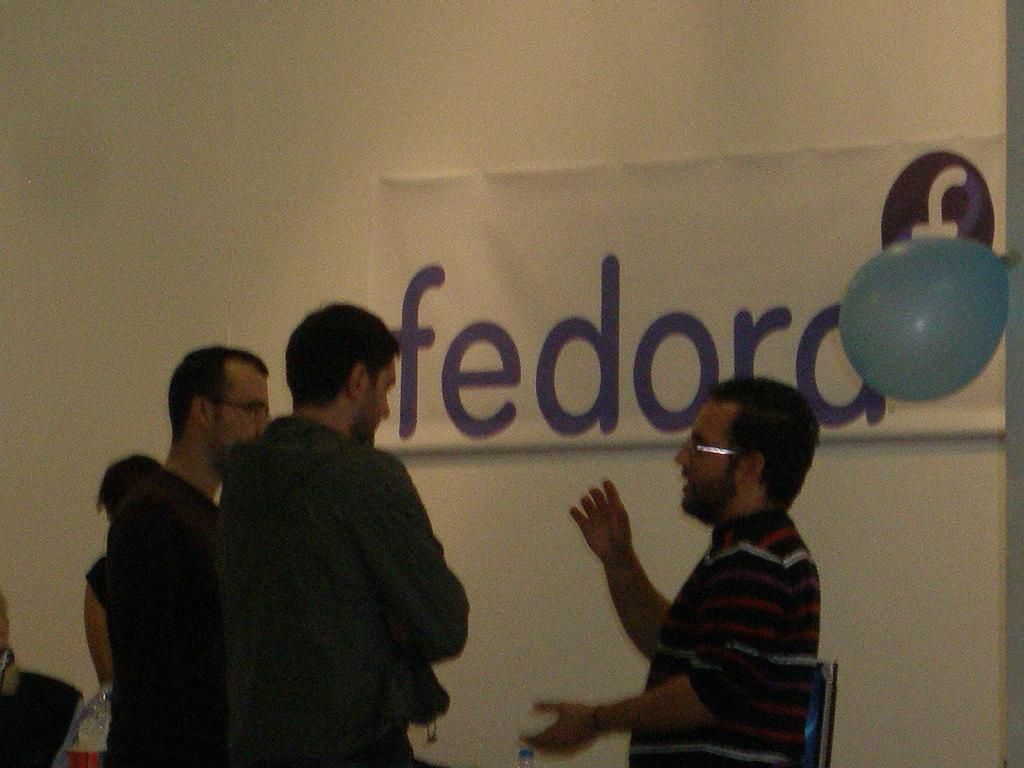Describe this image in one or two sentences. This picture describes about group of people, behind them we can see a monitor and a poster on the wall and also we can see a balloon on the right side of the image. 